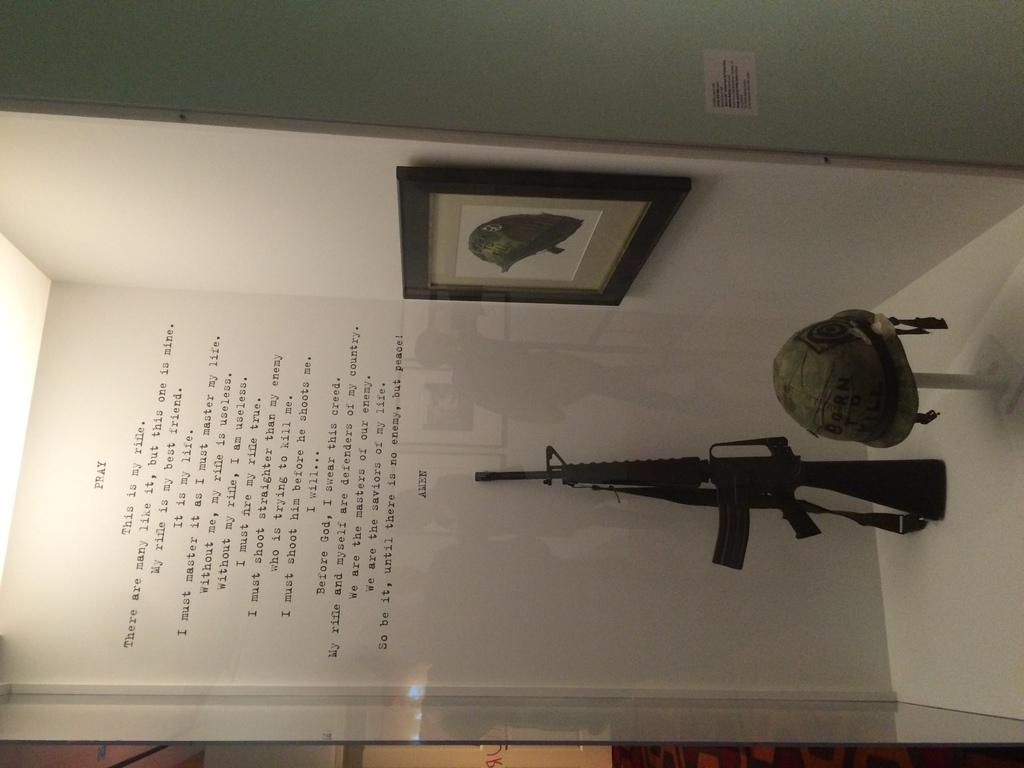How is the image oriented? The image is tilted. What can be seen on the enclosed surface in the image? There is a weapon kept on an enclosed surface in the image. What is written or displayed above the wall in the image? There is text above a wall in the image. What type of structure is attached to the wall in the image? There is a frame attached to the wall in the image. Can you see any icicles hanging from the weapon in the image? There are no icicles present in the image, as the focus is on the weapon and its location. --- 